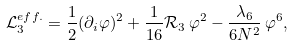<formula> <loc_0><loc_0><loc_500><loc_500>\mathcal { L } _ { 3 } ^ { e f f . } = \frac { 1 } { 2 } ( \partial _ { i } \varphi ) ^ { 2 } + \frac { 1 } { 1 6 } \mathcal { R } _ { 3 } \, \varphi ^ { 2 } - \frac { \lambda _ { 6 } } { 6 N ^ { 2 } } \, \varphi ^ { 6 } ,</formula> 